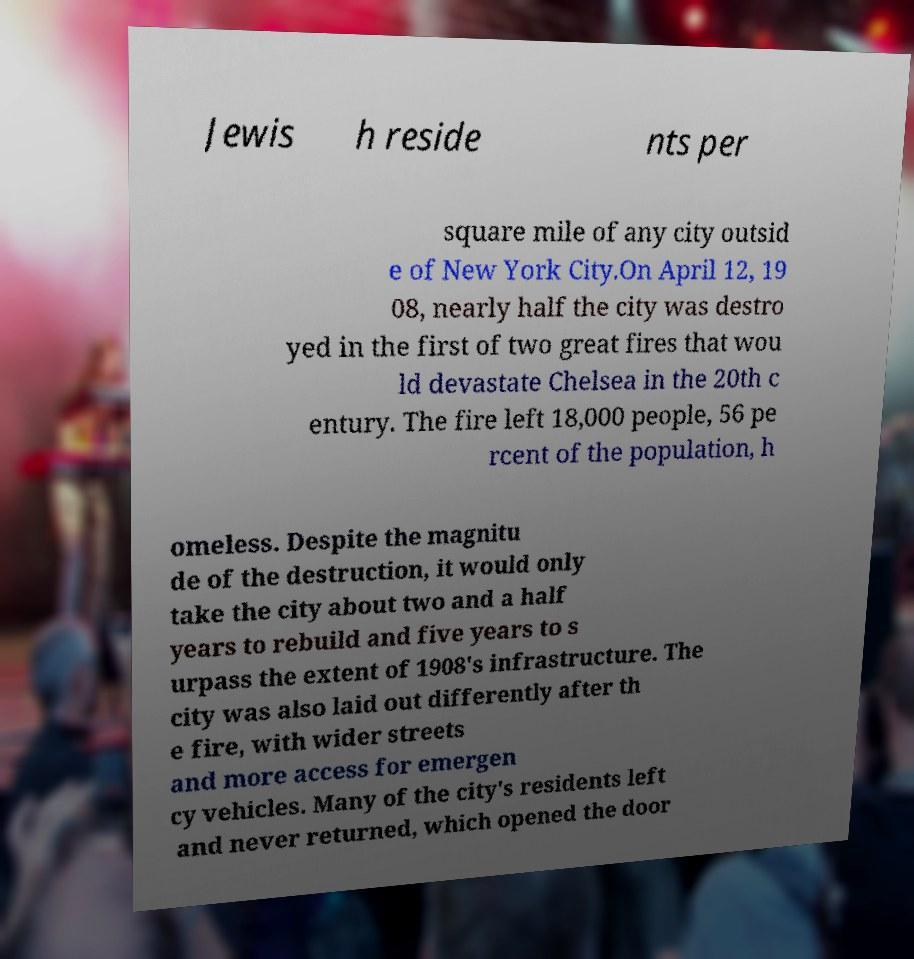Could you assist in decoding the text presented in this image and type it out clearly? Jewis h reside nts per square mile of any city outsid e of New York City.On April 12, 19 08, nearly half the city was destro yed in the first of two great fires that wou ld devastate Chelsea in the 20th c entury. The fire left 18,000 people, 56 pe rcent of the population, h omeless. Despite the magnitu de of the destruction, it would only take the city about two and a half years to rebuild and five years to s urpass the extent of 1908's infrastructure. The city was also laid out differently after th e fire, with wider streets and more access for emergen cy vehicles. Many of the city's residents left and never returned, which opened the door 